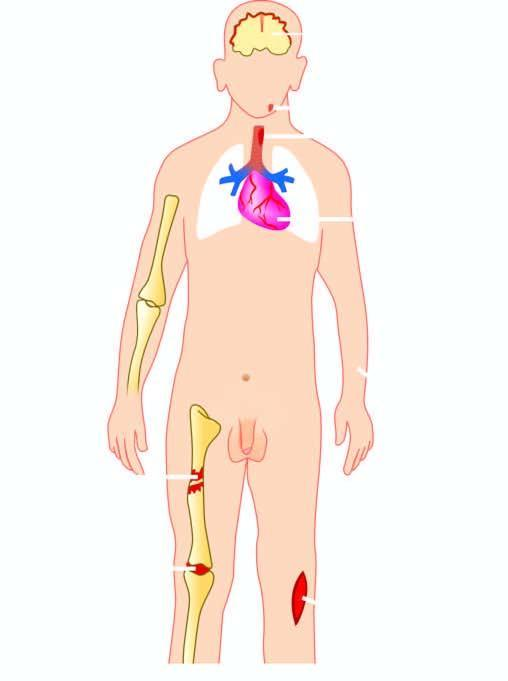what is suppurative diseases caused by?
Answer the question using a single word or phrase. Staphylococcus aureus 